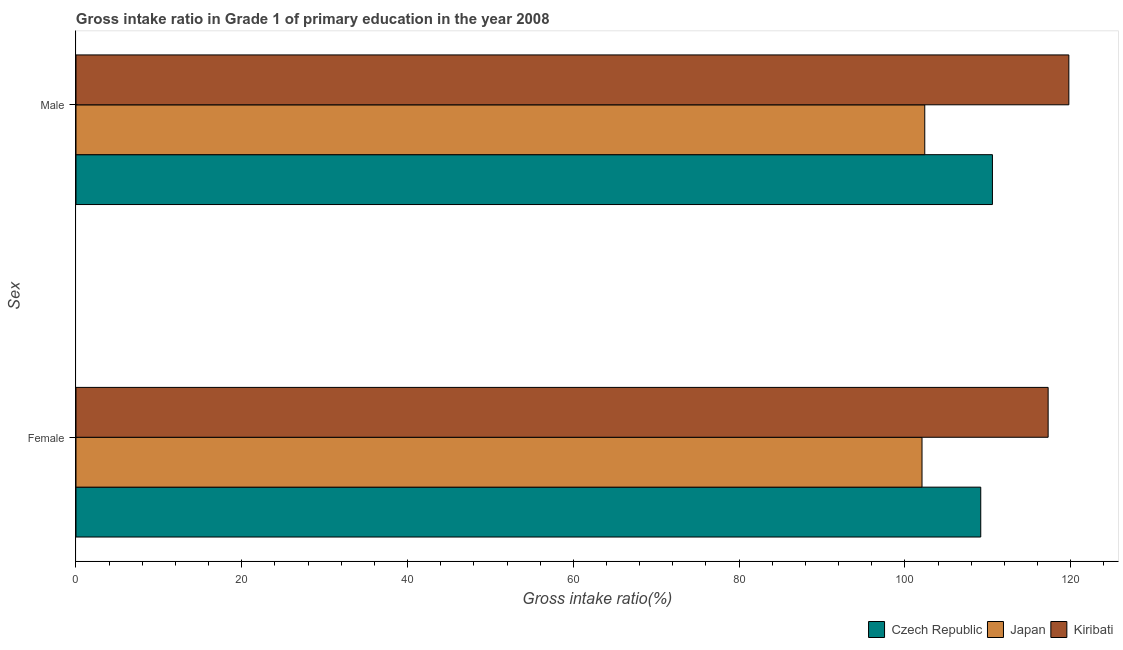Are the number of bars on each tick of the Y-axis equal?
Offer a very short reply. Yes. What is the label of the 2nd group of bars from the top?
Provide a succinct answer. Female. What is the gross intake ratio(female) in Kiribati?
Give a very brief answer. 117.29. Across all countries, what is the maximum gross intake ratio(female)?
Provide a short and direct response. 117.29. Across all countries, what is the minimum gross intake ratio(male)?
Make the answer very short. 102.4. In which country was the gross intake ratio(male) maximum?
Your response must be concise. Kiribati. In which country was the gross intake ratio(female) minimum?
Offer a terse response. Japan. What is the total gross intake ratio(female) in the graph?
Give a very brief answer. 328.51. What is the difference between the gross intake ratio(male) in Czech Republic and that in Japan?
Your answer should be compact. 8.16. What is the difference between the gross intake ratio(female) in Kiribati and the gross intake ratio(male) in Japan?
Offer a terse response. 14.88. What is the average gross intake ratio(female) per country?
Provide a short and direct response. 109.5. What is the difference between the gross intake ratio(male) and gross intake ratio(female) in Kiribati?
Your answer should be very brief. 2.5. In how many countries, is the gross intake ratio(male) greater than 28 %?
Make the answer very short. 3. What is the ratio of the gross intake ratio(male) in Kiribati to that in Czech Republic?
Provide a succinct answer. 1.08. Is the gross intake ratio(female) in Kiribati less than that in Czech Republic?
Provide a succinct answer. No. In how many countries, is the gross intake ratio(female) greater than the average gross intake ratio(female) taken over all countries?
Offer a very short reply. 1. What does the 2nd bar from the top in Male represents?
Ensure brevity in your answer.  Japan. How many bars are there?
Offer a very short reply. 6. How many countries are there in the graph?
Your response must be concise. 3. What is the difference between two consecutive major ticks on the X-axis?
Make the answer very short. 20. Are the values on the major ticks of X-axis written in scientific E-notation?
Keep it short and to the point. No. Where does the legend appear in the graph?
Offer a very short reply. Bottom right. How are the legend labels stacked?
Your answer should be compact. Horizontal. What is the title of the graph?
Make the answer very short. Gross intake ratio in Grade 1 of primary education in the year 2008. What is the label or title of the X-axis?
Provide a short and direct response. Gross intake ratio(%). What is the label or title of the Y-axis?
Make the answer very short. Sex. What is the Gross intake ratio(%) in Czech Republic in Female?
Your answer should be very brief. 109.16. What is the Gross intake ratio(%) in Japan in Female?
Keep it short and to the point. 102.07. What is the Gross intake ratio(%) of Kiribati in Female?
Offer a very short reply. 117.29. What is the Gross intake ratio(%) of Czech Republic in Male?
Offer a very short reply. 110.57. What is the Gross intake ratio(%) of Japan in Male?
Your response must be concise. 102.4. What is the Gross intake ratio(%) in Kiribati in Male?
Provide a short and direct response. 119.79. Across all Sex, what is the maximum Gross intake ratio(%) of Czech Republic?
Your answer should be very brief. 110.57. Across all Sex, what is the maximum Gross intake ratio(%) in Japan?
Ensure brevity in your answer.  102.4. Across all Sex, what is the maximum Gross intake ratio(%) in Kiribati?
Offer a terse response. 119.79. Across all Sex, what is the minimum Gross intake ratio(%) in Czech Republic?
Ensure brevity in your answer.  109.16. Across all Sex, what is the minimum Gross intake ratio(%) in Japan?
Offer a terse response. 102.07. Across all Sex, what is the minimum Gross intake ratio(%) of Kiribati?
Provide a succinct answer. 117.29. What is the total Gross intake ratio(%) of Czech Republic in the graph?
Keep it short and to the point. 219.72. What is the total Gross intake ratio(%) in Japan in the graph?
Keep it short and to the point. 204.47. What is the total Gross intake ratio(%) in Kiribati in the graph?
Keep it short and to the point. 237.07. What is the difference between the Gross intake ratio(%) in Czech Republic in Female and that in Male?
Your response must be concise. -1.41. What is the difference between the Gross intake ratio(%) of Japan in Female and that in Male?
Make the answer very short. -0.33. What is the difference between the Gross intake ratio(%) in Kiribati in Female and that in Male?
Give a very brief answer. -2.5. What is the difference between the Gross intake ratio(%) in Czech Republic in Female and the Gross intake ratio(%) in Japan in Male?
Make the answer very short. 6.75. What is the difference between the Gross intake ratio(%) in Czech Republic in Female and the Gross intake ratio(%) in Kiribati in Male?
Offer a terse response. -10.63. What is the difference between the Gross intake ratio(%) of Japan in Female and the Gross intake ratio(%) of Kiribati in Male?
Offer a terse response. -17.72. What is the average Gross intake ratio(%) in Czech Republic per Sex?
Offer a terse response. 109.86. What is the average Gross intake ratio(%) in Japan per Sex?
Offer a terse response. 102.24. What is the average Gross intake ratio(%) of Kiribati per Sex?
Your response must be concise. 118.54. What is the difference between the Gross intake ratio(%) in Czech Republic and Gross intake ratio(%) in Japan in Female?
Make the answer very short. 7.09. What is the difference between the Gross intake ratio(%) of Czech Republic and Gross intake ratio(%) of Kiribati in Female?
Make the answer very short. -8.13. What is the difference between the Gross intake ratio(%) in Japan and Gross intake ratio(%) in Kiribati in Female?
Keep it short and to the point. -15.22. What is the difference between the Gross intake ratio(%) of Czech Republic and Gross intake ratio(%) of Japan in Male?
Provide a short and direct response. 8.16. What is the difference between the Gross intake ratio(%) in Czech Republic and Gross intake ratio(%) in Kiribati in Male?
Provide a short and direct response. -9.22. What is the difference between the Gross intake ratio(%) in Japan and Gross intake ratio(%) in Kiribati in Male?
Offer a terse response. -17.38. What is the ratio of the Gross intake ratio(%) in Czech Republic in Female to that in Male?
Ensure brevity in your answer.  0.99. What is the ratio of the Gross intake ratio(%) of Kiribati in Female to that in Male?
Give a very brief answer. 0.98. What is the difference between the highest and the second highest Gross intake ratio(%) in Czech Republic?
Your answer should be very brief. 1.41. What is the difference between the highest and the second highest Gross intake ratio(%) in Japan?
Provide a short and direct response. 0.33. What is the difference between the highest and the second highest Gross intake ratio(%) in Kiribati?
Provide a succinct answer. 2.5. What is the difference between the highest and the lowest Gross intake ratio(%) in Czech Republic?
Keep it short and to the point. 1.41. What is the difference between the highest and the lowest Gross intake ratio(%) in Japan?
Make the answer very short. 0.33. What is the difference between the highest and the lowest Gross intake ratio(%) of Kiribati?
Make the answer very short. 2.5. 